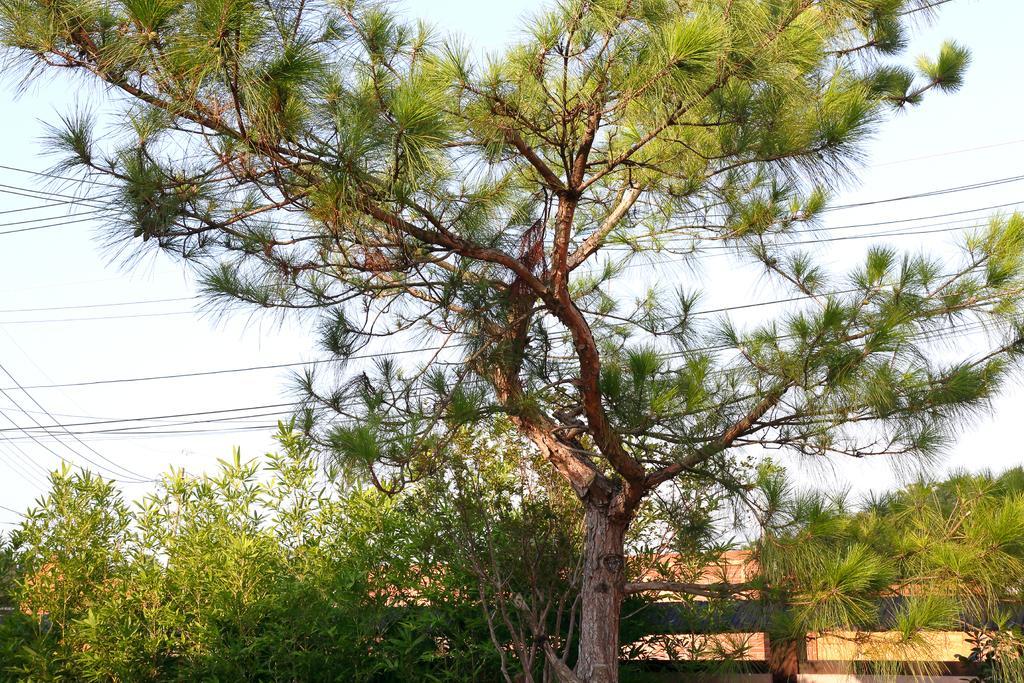In one or two sentences, can you explain what this image depicts? In the center of the image we can see a tree. We can also see a fence, a group of plants, wires and the sky which looks cloudy. 